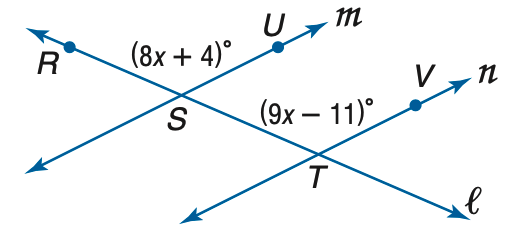Answer the mathemtical geometry problem and directly provide the correct option letter.
Question: Find m \angle R S U so that m \parallel n.
Choices: A: 114 B: 116 C: 120 D: 124 D 